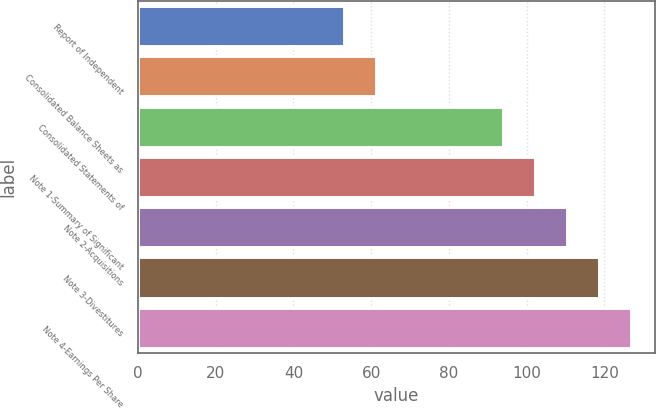Convert chart. <chart><loc_0><loc_0><loc_500><loc_500><bar_chart><fcel>Report of Independent<fcel>Consolidated Balance Sheets as<fcel>Consolidated Statements of<fcel>Note 1-Summary of Significant<fcel>Note 2-Acquisitions<fcel>Note 3-Divestitures<fcel>Note 4-Earnings Per Share<nl><fcel>53<fcel>61.2<fcel>94<fcel>102.2<fcel>110.4<fcel>118.6<fcel>126.8<nl></chart> 